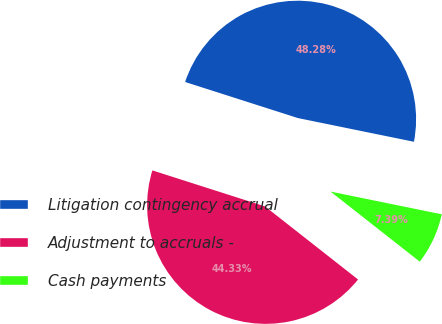Convert chart. <chart><loc_0><loc_0><loc_500><loc_500><pie_chart><fcel>Litigation contingency accrual<fcel>Adjustment to accruals -<fcel>Cash payments<nl><fcel>48.28%<fcel>44.33%<fcel>7.39%<nl></chart> 